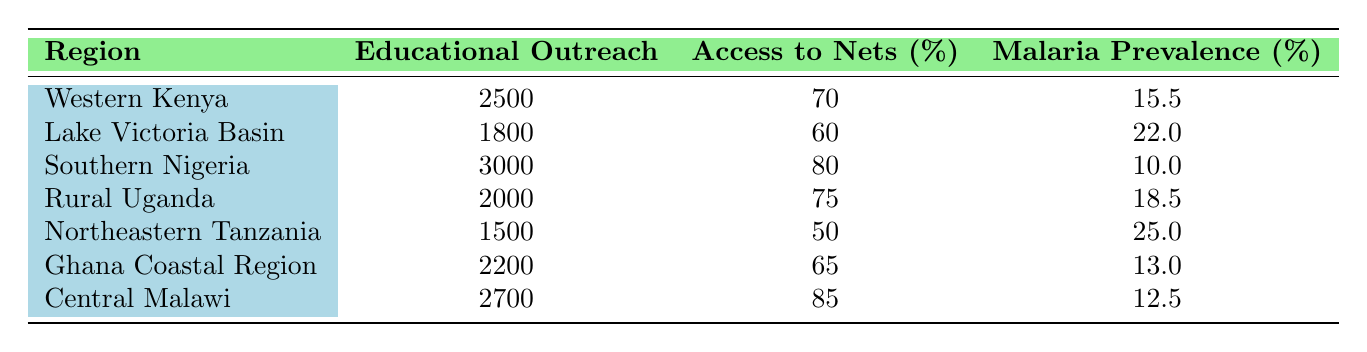What is the prevalence of malaria in Southern Nigeria? The table lists Southern Nigeria with a malaria prevalence of 10.0%.
Answer: 10.0 Which region has the highest access to nets? Examining the table, Central Malawi has the highest access to nets at 85%.
Answer: 85 Are there more educational outreach participants in Rural Uganda than in Ghana Coastal Region? Rural Uganda has 2000 participants, while Ghana Coastal Region has 2200 participants. Therefore, there are fewer participants in Rural Uganda than in Ghana Coastal Region.
Answer: No What is the average malaria prevalence across all regions listed? To calculate the average, add the malaria prevalence percentages: (15.5 + 22.0 + 10.0 + 18.5 + 25.0 + 13.0 + 12.5) = 116.5. There are 7 regions, so the average prevalence is 116.5 / 7 = 16.64.
Answer: 16.64 Is the educational outreach in the Lake Victoria Basin higher than in Northeastern Tanzania? The table states that Lake Victoria Basin has 1800 educational outreach participants, while Northeastern Tanzania has 1500 participants. Therefore, Lake Victoria Basin has a higher number of participants.
Answer: Yes What is the difference in the percentage of malaria prevalence between the region with the highest and lowest access to nets? The region with the highest access to nets is Central Malawi at 12.5% prevalence, and the lowest is Northeastern Tanzania at 25.0%. The difference is 25.0 - 12.5 = 12.5%.
Answer: 12.5 Which region has the lowest educational outreach participation? From the data, Northeastern Tanzania has 1500 educational outreach participants, making it the region with the lowest participation.
Answer: Northeastern Tanzania Does the data suggest that higher access to nets correlates with lower malaria prevalence? To analyze this, we can look at the regions with high access to nets like Central Malawi (85% access, 12.5% prevalence), and Southern Nigeria (80% access, 10.0% prevalence) with a lower prevalence compared to regions with lower access, such as Northeastern Tanzania (50% access, 25.0% prevalence). While this suggests a trend, we must consider the possibility of other factors influencing malaria prevalence.
Answer: Yes, generally 